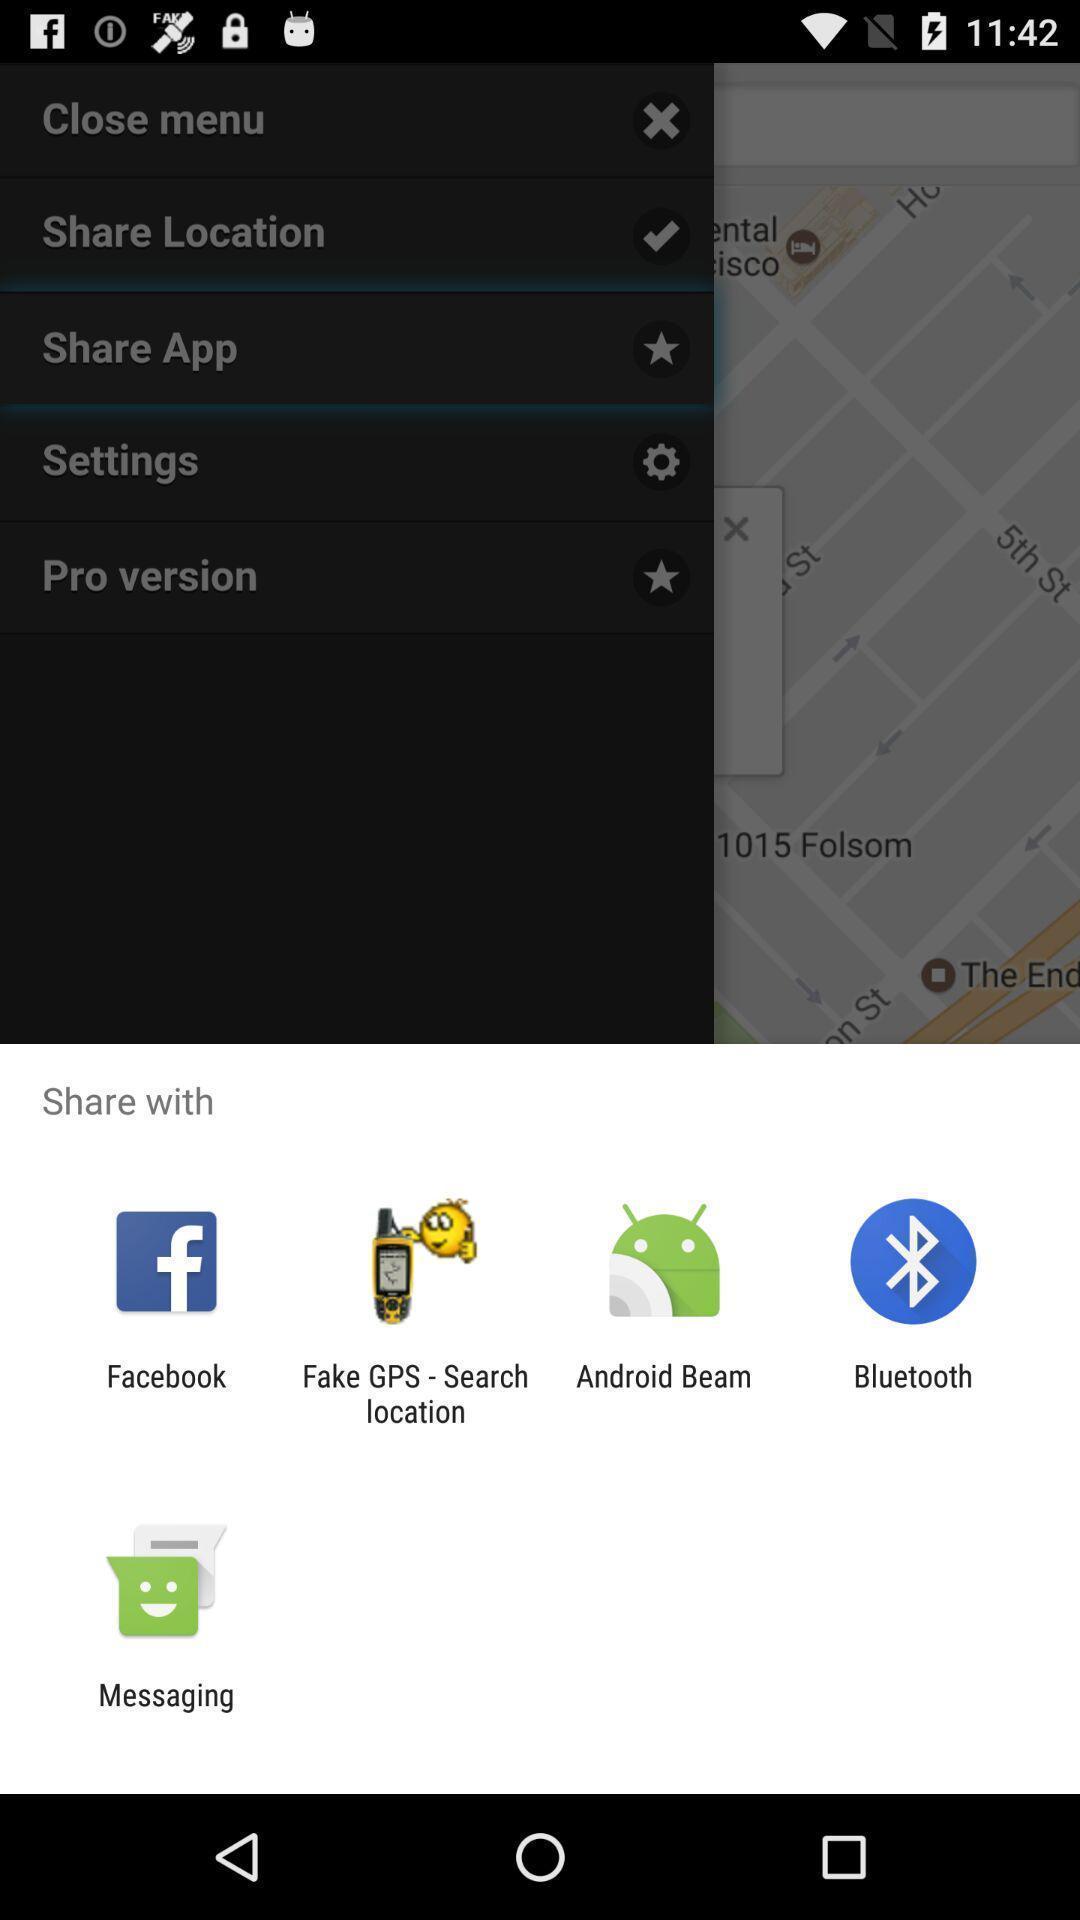What can you discern from this picture? Push up message for sharing app via social network. 